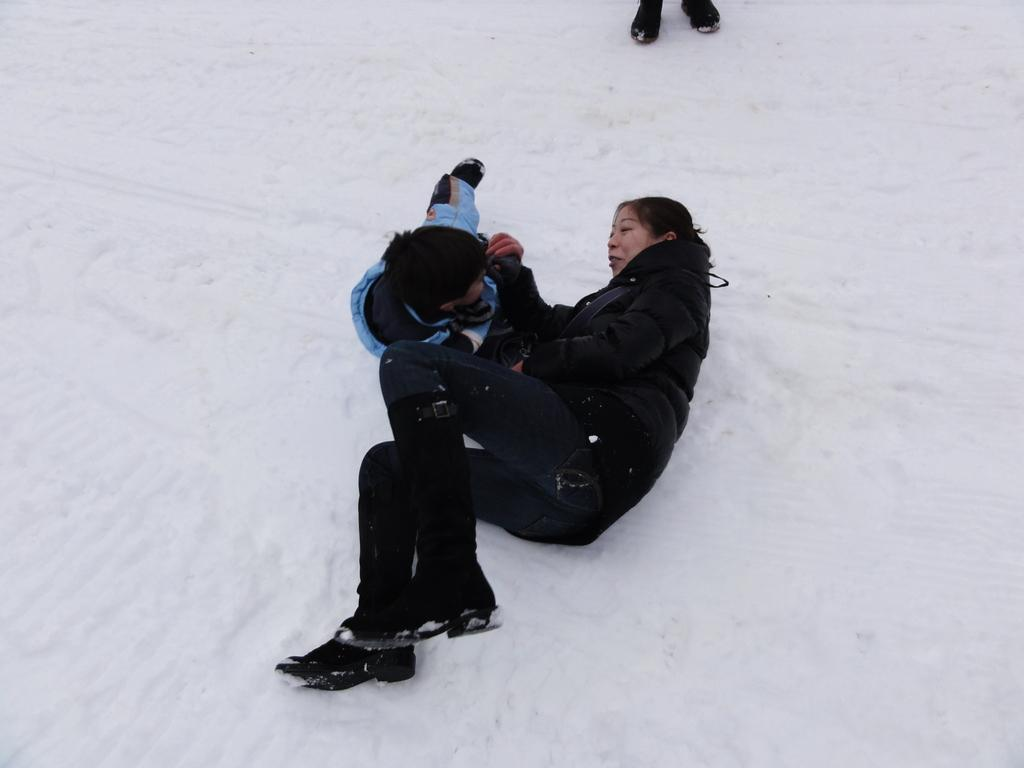What is the condition of the ground in the image? The ground is covered with snow in the image. Who are the people in the image? There is a woman and a boy in the image. Where are the woman and the boy located in the image? Both the woman and the boy are on the ground. What are the woman and the boy doing in the image? The woman and the boy are staring at each other. What type of growth can be seen on the kettle in the image? There is no kettle present in the image, so no growth can be observed. 